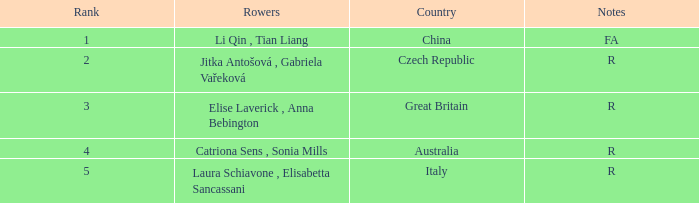What is the Rank of the Rowers with FA as Notes? 1.0. Would you be able to parse every entry in this table? {'header': ['Rank', 'Rowers', 'Country', 'Notes'], 'rows': [['1', 'Li Qin , Tian Liang', 'China', 'FA'], ['2', 'Jitka Antošová , Gabriela Vařeková', 'Czech Republic', 'R'], ['3', 'Elise Laverick , Anna Bebington', 'Great Britain', 'R'], ['4', 'Catriona Sens , Sonia Mills', 'Australia', 'R'], ['5', 'Laura Schiavone , Elisabetta Sancassani', 'Italy', 'R']]} 